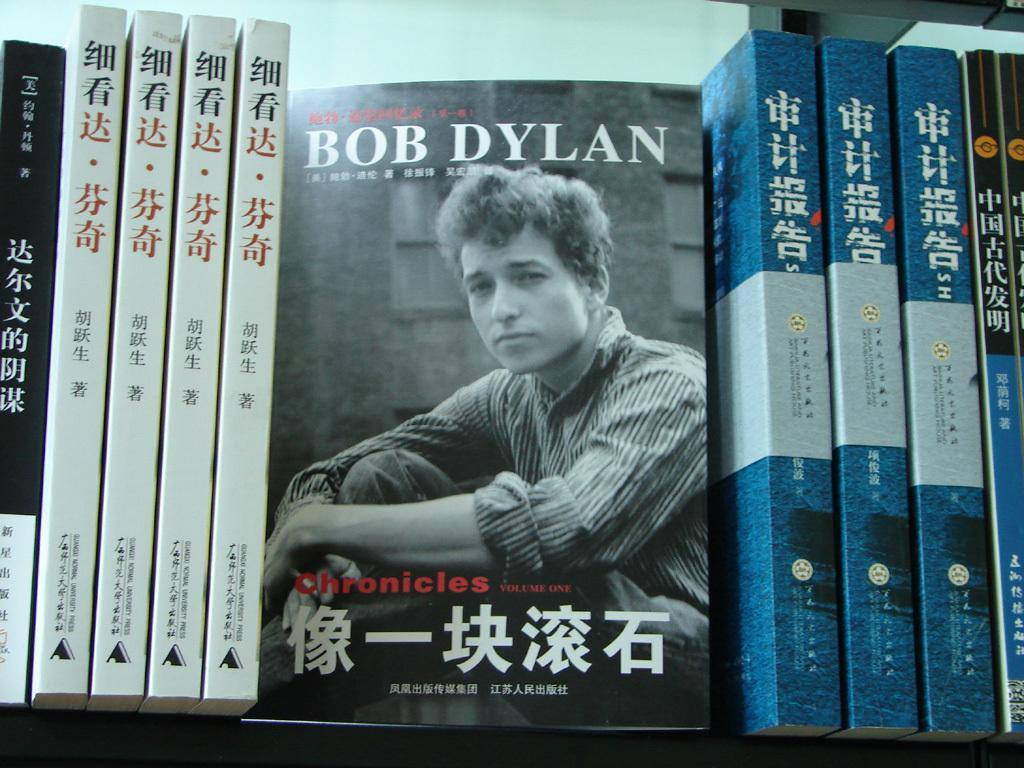<image>
Summarize the visual content of the image. A bookshelf with a book about Bob Dylan on it. 